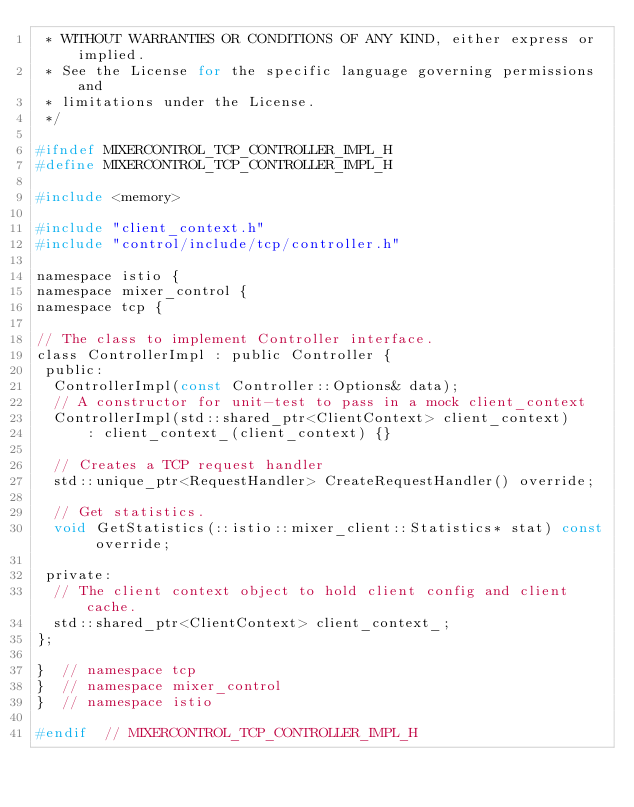<code> <loc_0><loc_0><loc_500><loc_500><_C_> * WITHOUT WARRANTIES OR CONDITIONS OF ANY KIND, either express or implied.
 * See the License for the specific language governing permissions and
 * limitations under the License.
 */

#ifndef MIXERCONTROL_TCP_CONTROLLER_IMPL_H
#define MIXERCONTROL_TCP_CONTROLLER_IMPL_H

#include <memory>

#include "client_context.h"
#include "control/include/tcp/controller.h"

namespace istio {
namespace mixer_control {
namespace tcp {

// The class to implement Controller interface.
class ControllerImpl : public Controller {
 public:
  ControllerImpl(const Controller::Options& data);
  // A constructor for unit-test to pass in a mock client_context
  ControllerImpl(std::shared_ptr<ClientContext> client_context)
      : client_context_(client_context) {}

  // Creates a TCP request handler
  std::unique_ptr<RequestHandler> CreateRequestHandler() override;

  // Get statistics.
  void GetStatistics(::istio::mixer_client::Statistics* stat) const override;

 private:
  // The client context object to hold client config and client cache.
  std::shared_ptr<ClientContext> client_context_;
};

}  // namespace tcp
}  // namespace mixer_control
}  // namespace istio

#endif  // MIXERCONTROL_TCP_CONTROLLER_IMPL_H
</code> 